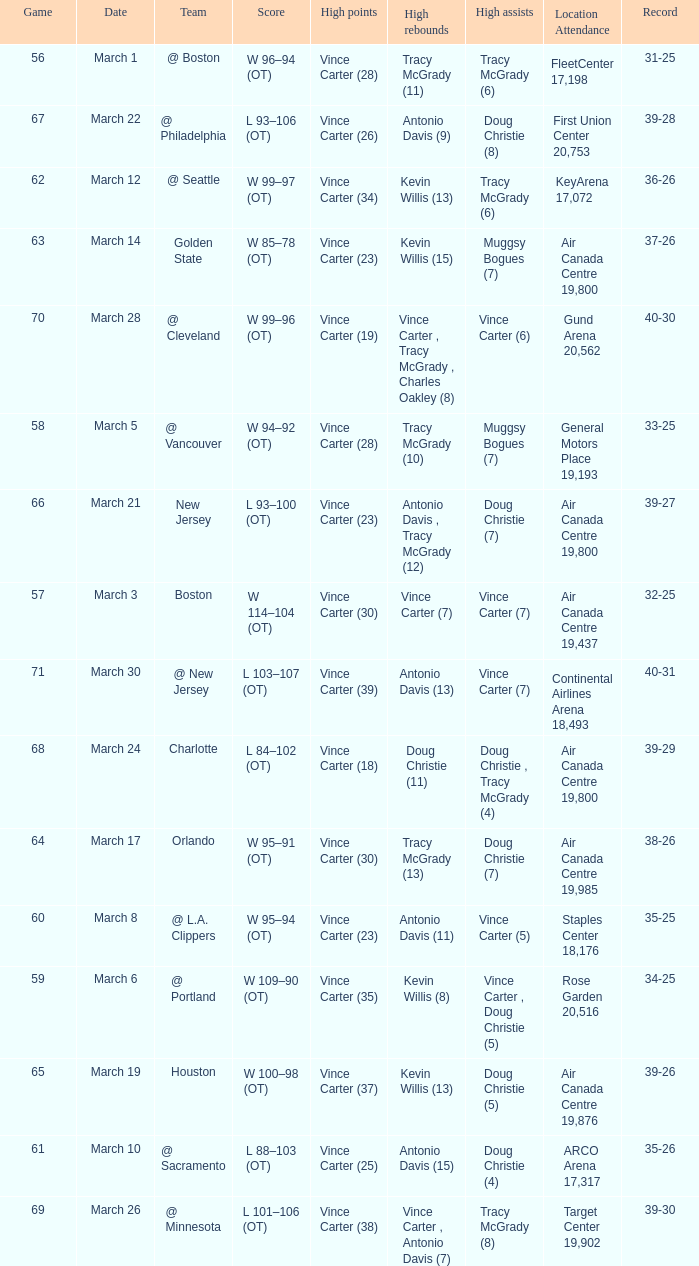Who was the high rebounder against charlotte? Doug Christie (11). 